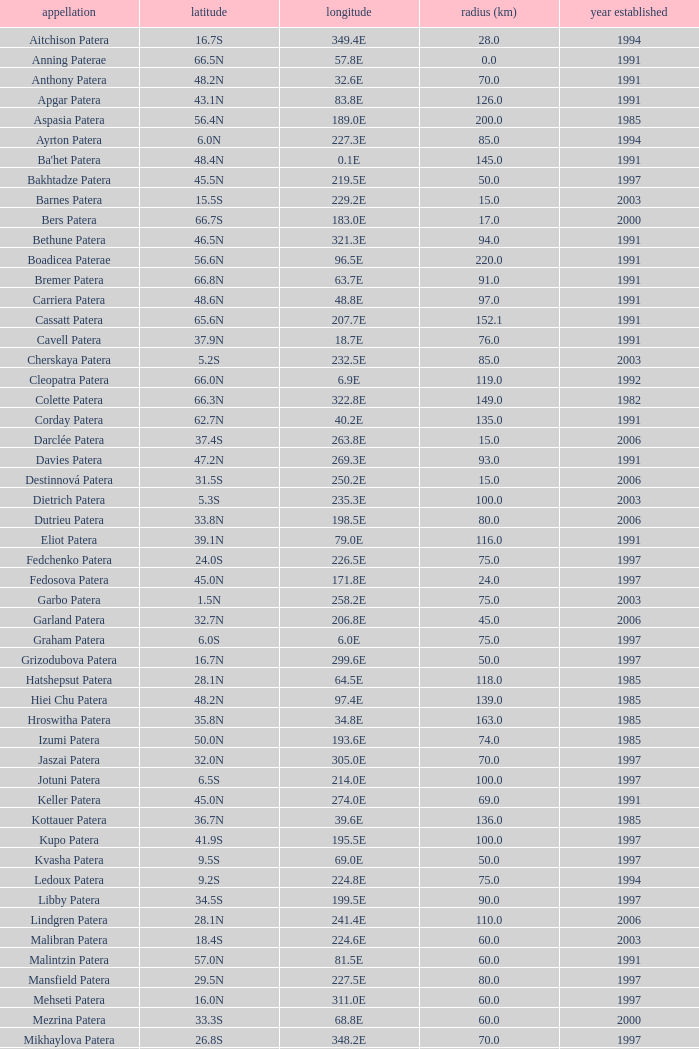What is Year Named, when Longitude is 227.5E? 1997.0. 